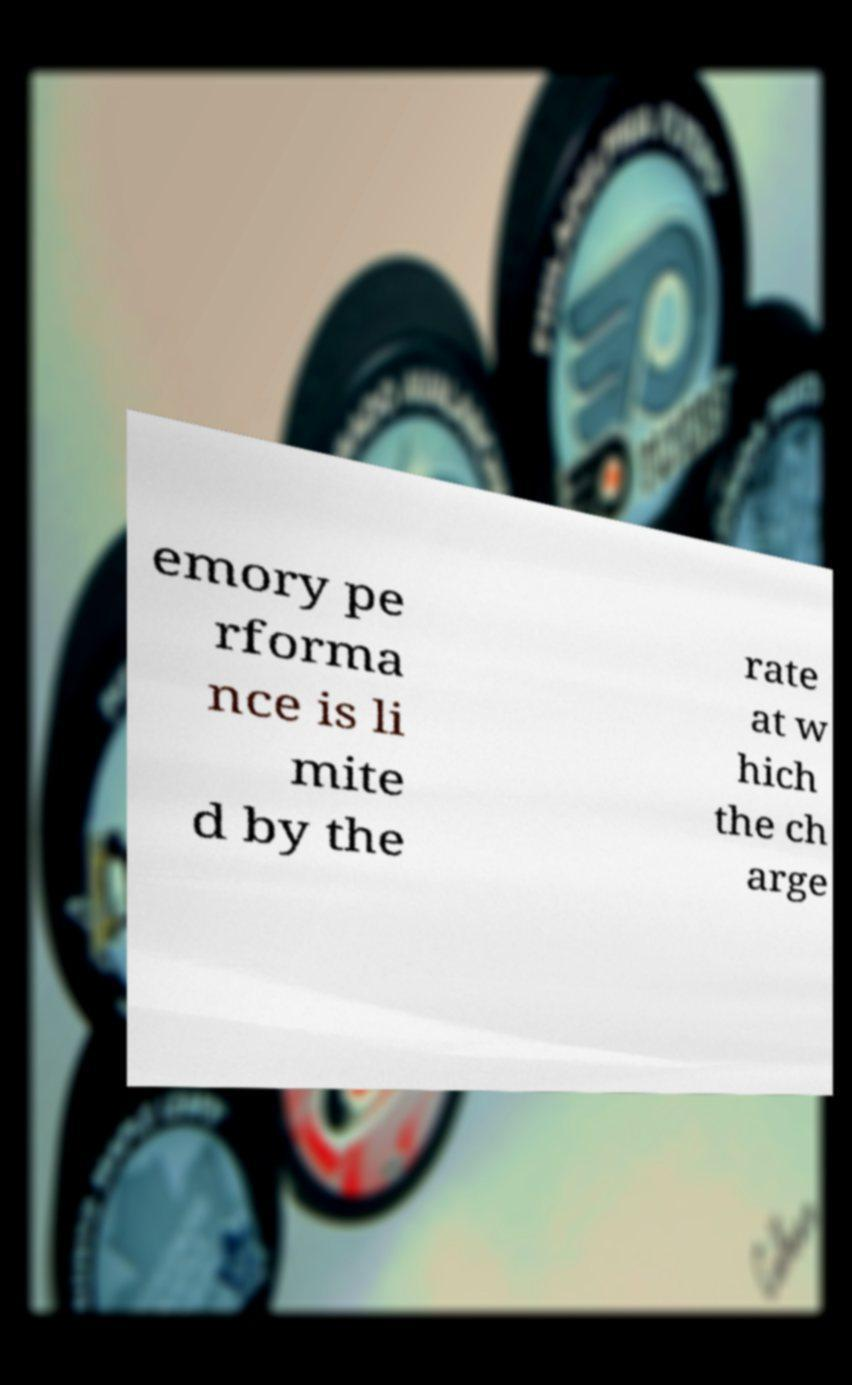I need the written content from this picture converted into text. Can you do that? emory pe rforma nce is li mite d by the rate at w hich the ch arge 